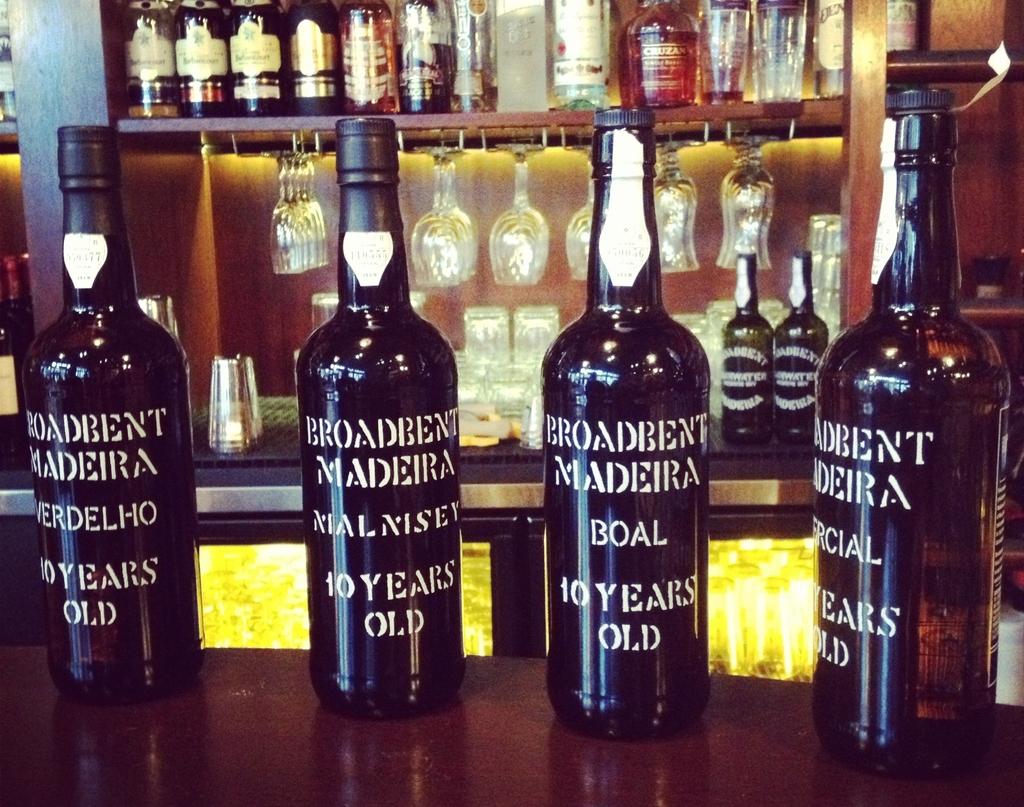What color is the word "boal" on the third bottle from the left?
Your response must be concise. White. 